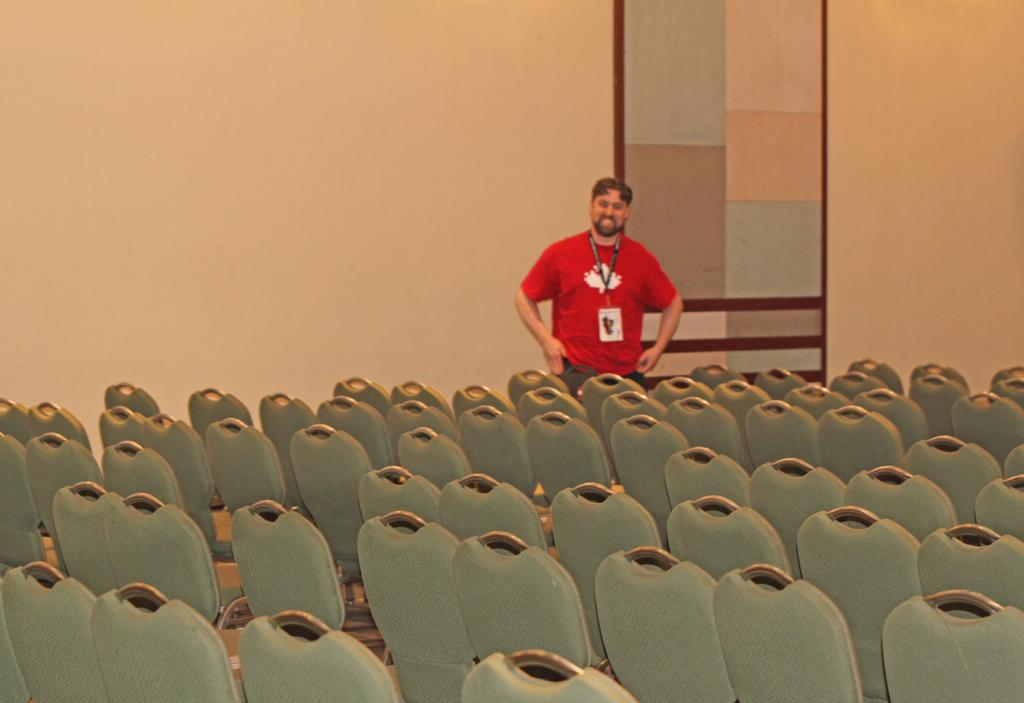What color are the chairs in the image? The chairs in the image are grey. What is the person wearing in the image? The person is wearing a red color T-shirt in the image. What is the person holding in the image? The person is holding an identity card in the image. What is the person doing in the image? The person is standing and smiling in the image. What can be seen in the background of the image? There is a wall in the background of the image. What type of pie is being served on the table in the image? There is no table or pie present in the image. What flavor of mint can be smelled in the image? There is no mint present in the image, so it cannot be smelled or identified. 